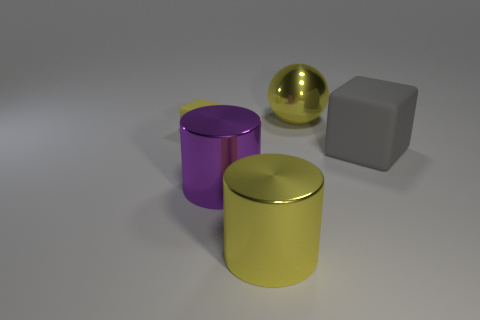Are there any big yellow shiny things of the same shape as the purple object?
Your answer should be compact. Yes. There is a purple metal object that is the same size as the yellow metallic cylinder; what is its shape?
Give a very brief answer. Cylinder. How many objects are either large metal things in front of the large yellow shiny ball or large objects?
Give a very brief answer. 4. Does the big ball have the same color as the small rubber thing?
Provide a succinct answer. Yes. What is the size of the rubber block that is on the right side of the large ball?
Ensure brevity in your answer.  Large. Are there any purple metal objects of the same size as the yellow metal cylinder?
Provide a short and direct response. Yes. There is a rubber object that is on the left side of the yellow shiny sphere; is it the same size as the big purple thing?
Provide a short and direct response. No. How big is the ball?
Provide a short and direct response. Large. What is the color of the block that is right of the thing behind the thing that is to the left of the big purple metal object?
Give a very brief answer. Gray. There is a rubber block that is on the left side of the big rubber thing; is it the same color as the big metallic sphere?
Provide a short and direct response. Yes. 